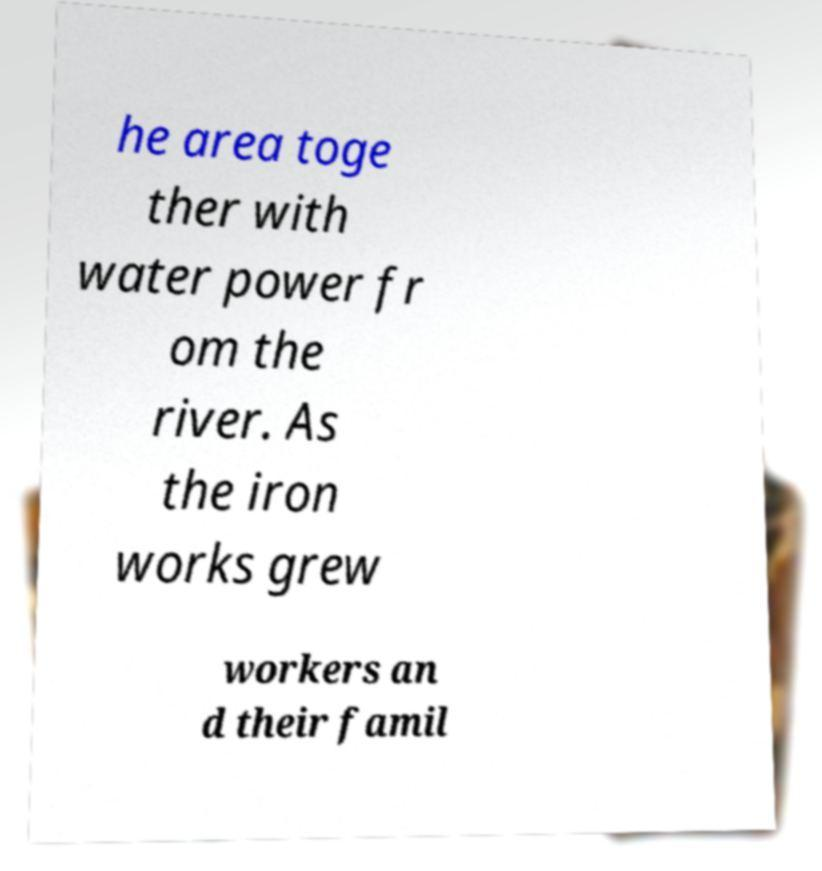There's text embedded in this image that I need extracted. Can you transcribe it verbatim? he area toge ther with water power fr om the river. As the iron works grew workers an d their famil 